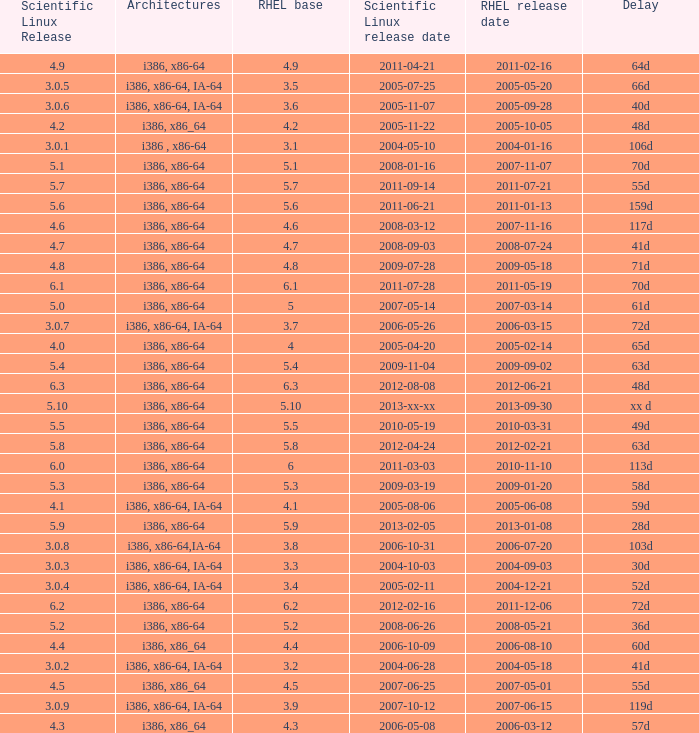4? 2004-12-21. 